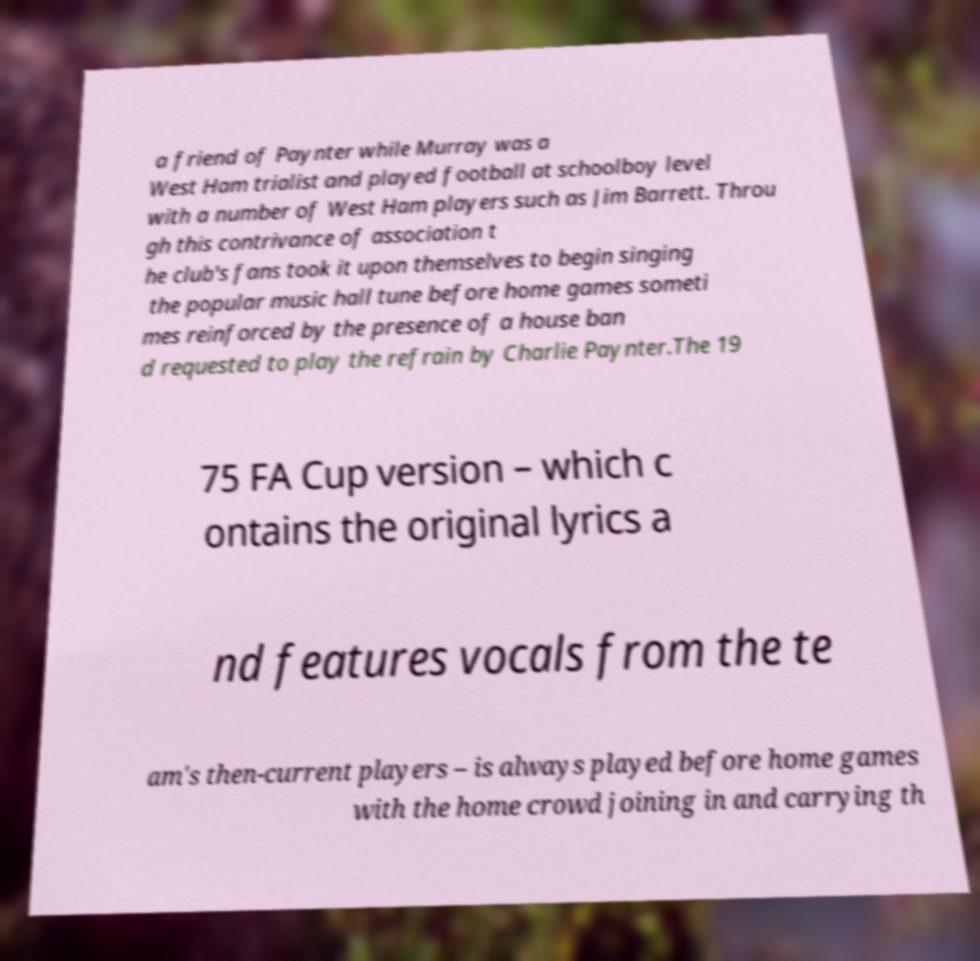Could you assist in decoding the text presented in this image and type it out clearly? a friend of Paynter while Murray was a West Ham trialist and played football at schoolboy level with a number of West Ham players such as Jim Barrett. Throu gh this contrivance of association t he club's fans took it upon themselves to begin singing the popular music hall tune before home games someti mes reinforced by the presence of a house ban d requested to play the refrain by Charlie Paynter.The 19 75 FA Cup version – which c ontains the original lyrics a nd features vocals from the te am's then-current players – is always played before home games with the home crowd joining in and carrying th 